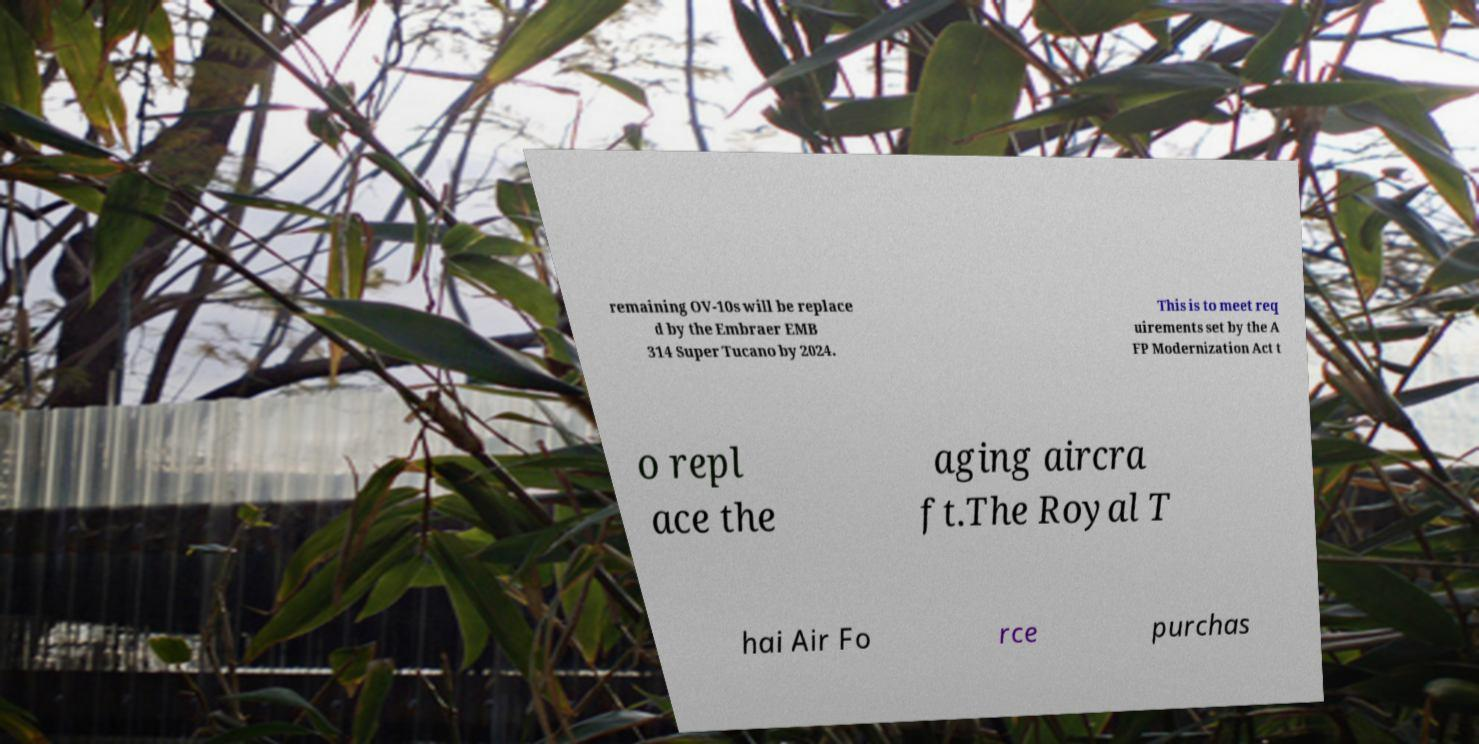For documentation purposes, I need the text within this image transcribed. Could you provide that? remaining OV-10s will be replace d by the Embraer EMB 314 Super Tucano by 2024. This is to meet req uirements set by the A FP Modernization Act t o repl ace the aging aircra ft.The Royal T hai Air Fo rce purchas 